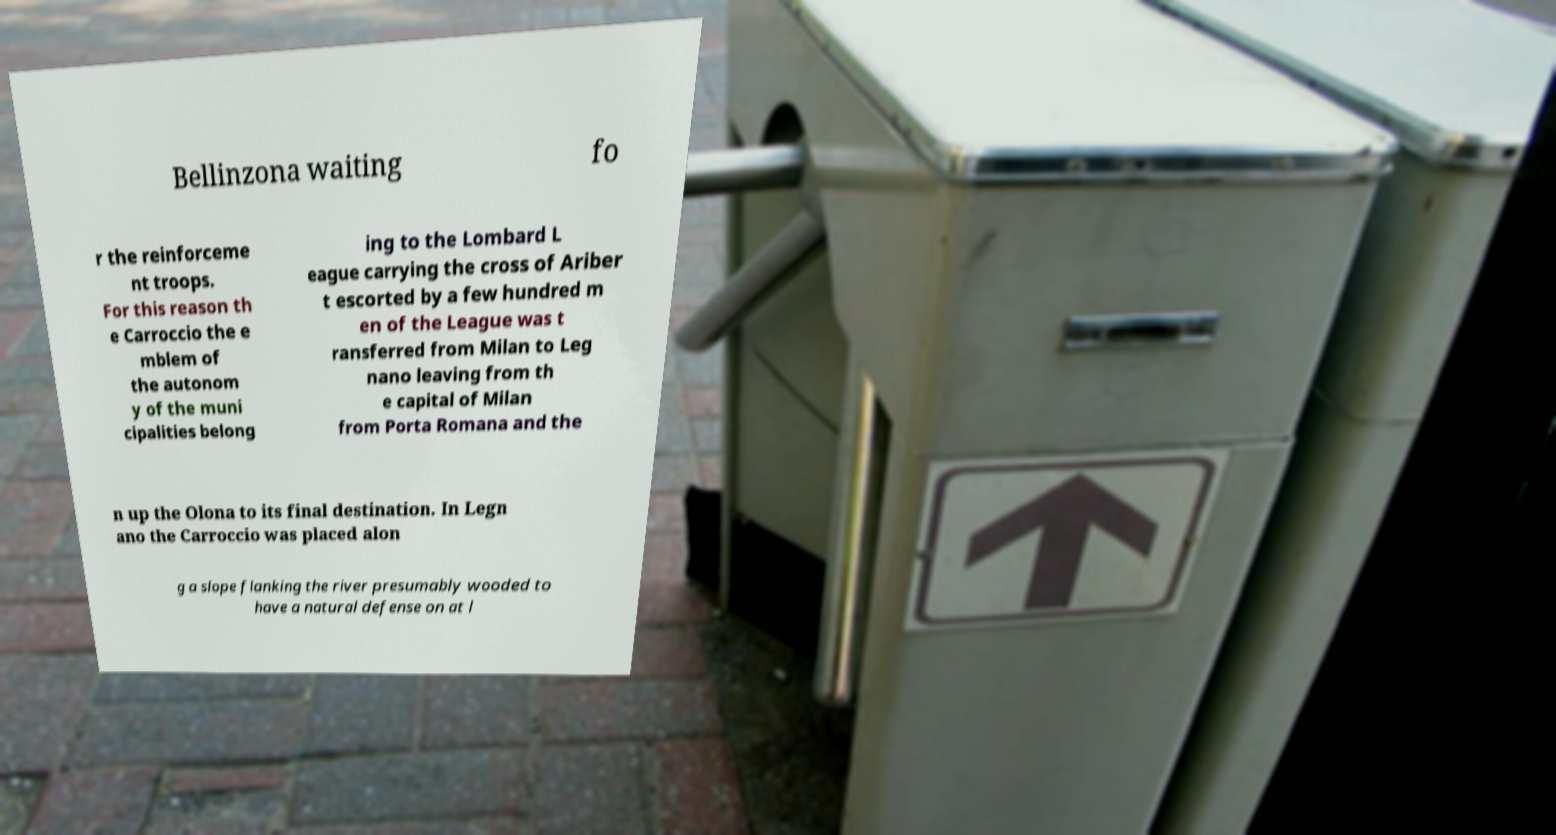For documentation purposes, I need the text within this image transcribed. Could you provide that? Bellinzona waiting fo r the reinforceme nt troops. For this reason th e Carroccio the e mblem of the autonom y of the muni cipalities belong ing to the Lombard L eague carrying the cross of Ariber t escorted by a few hundred m en of the League was t ransferred from Milan to Leg nano leaving from th e capital of Milan from Porta Romana and the n up the Olona to its final destination. In Legn ano the Carroccio was placed alon g a slope flanking the river presumably wooded to have a natural defense on at l 